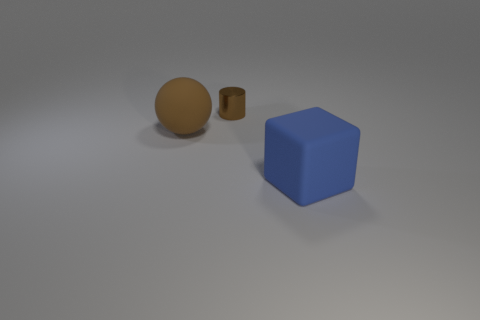There is a large matte thing that is to the left of the metallic object; is it the same shape as the small brown object?
Your answer should be very brief. No. Do the tiny cylinder and the big matte block have the same color?
Your answer should be very brief. No. How many things are brown objects that are to the right of the brown rubber object or large blue things?
Provide a short and direct response. 2. What shape is the brown rubber thing that is the same size as the blue cube?
Your answer should be very brief. Sphere. Does the brown object that is in front of the small cylinder have the same size as the matte object right of the small brown cylinder?
Your answer should be compact. Yes. What color is the cube that is the same material as the large brown ball?
Your response must be concise. Blue. Does the thing that is on the left side of the shiny thing have the same material as the large thing to the right of the tiny brown object?
Give a very brief answer. Yes. Are there any brown shiny objects of the same size as the block?
Ensure brevity in your answer.  No. There is a cube that is in front of the brown thing that is behind the brown matte sphere; what size is it?
Keep it short and to the point. Large. How many metal objects have the same color as the sphere?
Your response must be concise. 1. 